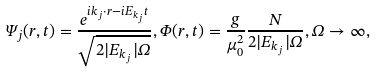Convert formula to latex. <formula><loc_0><loc_0><loc_500><loc_500>\Psi _ { j } ( r , t ) = \frac { e ^ { i k _ { j } \cdot r - i E _ { k _ { j } } t } } { \sqrt { 2 | E _ { k _ { j } } | \Omega } } , \Phi ( r , t ) = \frac { g } { \mu _ { 0 } ^ { 2 } } \frac { N } { 2 | E _ { k _ { j } } | \Omega } , \Omega \rightarrow \infty ,</formula> 